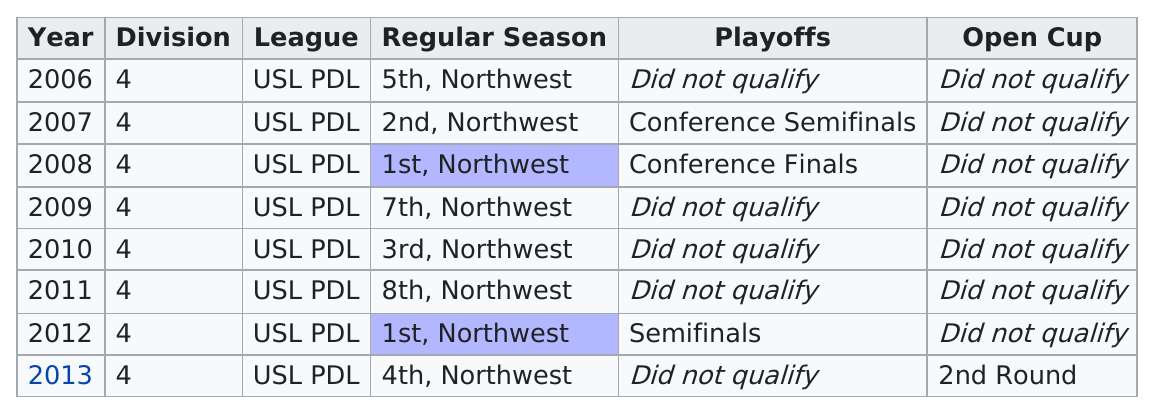Identify some key points in this picture. The Seattle Sounders have advanced to the second round of the Lamar Hunt U.S. Open Cup on 1 occasion. For a consecutive number of years, the Seattle Sounders did not qualify for the Open Cup, with the total number being 7. During the years 2006 to 2013, the Tacoma team failed to qualify for the playoffs a total of 5 times. The Seattle Sounders qualified for the Open Cup in the year 2013, making it the only year in which they have achieved this feat. In the years following 2007, Division 4 qualified for the playoffs a total of two times. 